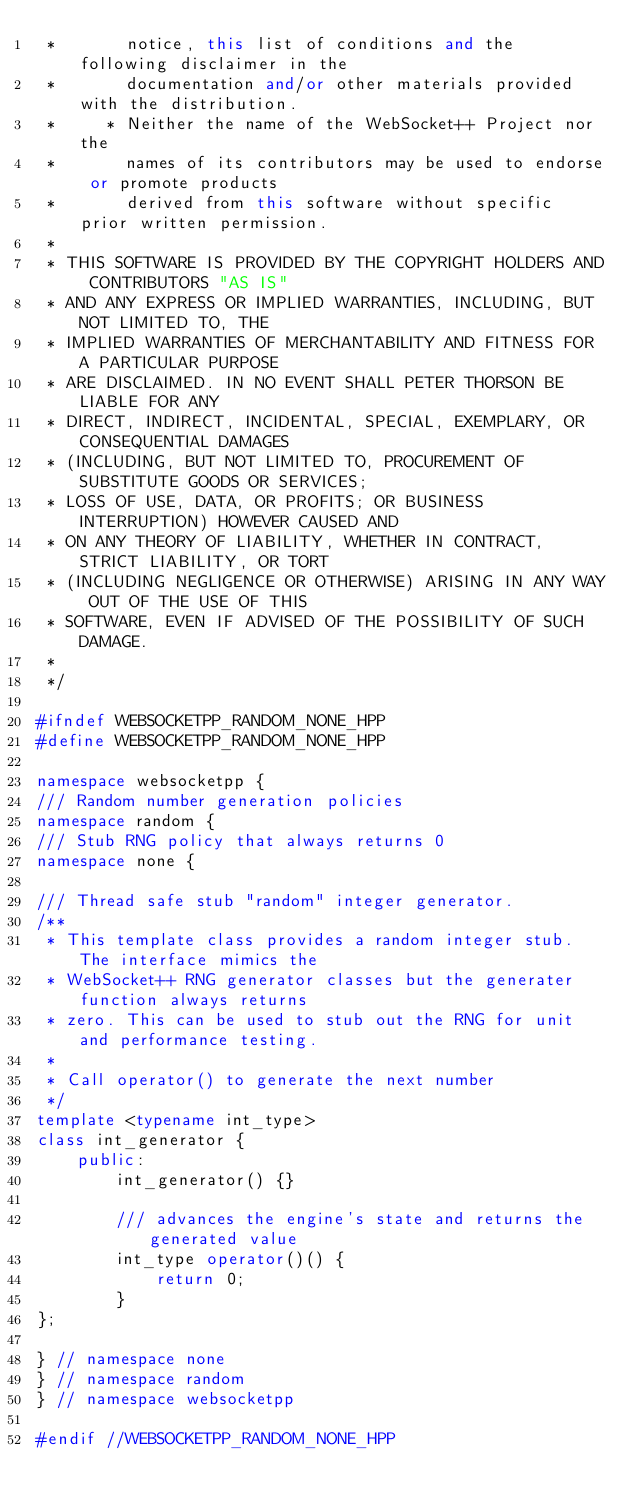Convert code to text. <code><loc_0><loc_0><loc_500><loc_500><_C++_> *       notice, this list of conditions and the following disclaimer in the
 *       documentation and/or other materials provided with the distribution.
 *     * Neither the name of the WebSocket++ Project nor the
 *       names of its contributors may be used to endorse or promote products
 *       derived from this software without specific prior written permission.
 *
 * THIS SOFTWARE IS PROVIDED BY THE COPYRIGHT HOLDERS AND CONTRIBUTORS "AS IS"
 * AND ANY EXPRESS OR IMPLIED WARRANTIES, INCLUDING, BUT NOT LIMITED TO, THE
 * IMPLIED WARRANTIES OF MERCHANTABILITY AND FITNESS FOR A PARTICULAR PURPOSE
 * ARE DISCLAIMED. IN NO EVENT SHALL PETER THORSON BE LIABLE FOR ANY
 * DIRECT, INDIRECT, INCIDENTAL, SPECIAL, EXEMPLARY, OR CONSEQUENTIAL DAMAGES
 * (INCLUDING, BUT NOT LIMITED TO, PROCUREMENT OF SUBSTITUTE GOODS OR SERVICES;
 * LOSS OF USE, DATA, OR PROFITS; OR BUSINESS INTERRUPTION) HOWEVER CAUSED AND
 * ON ANY THEORY OF LIABILITY, WHETHER IN CONTRACT, STRICT LIABILITY, OR TORT
 * (INCLUDING NEGLIGENCE OR OTHERWISE) ARISING IN ANY WAY OUT OF THE USE OF THIS
 * SOFTWARE, EVEN IF ADVISED OF THE POSSIBILITY OF SUCH DAMAGE.
 *
 */

#ifndef WEBSOCKETPP_RANDOM_NONE_HPP
#define WEBSOCKETPP_RANDOM_NONE_HPP

namespace websocketpp {
/// Random number generation policies
namespace random {
/// Stub RNG policy that always returns 0
namespace none {

/// Thread safe stub "random" integer generator.
/**
 * This template class provides a random integer stub. The interface mimics the
 * WebSocket++ RNG generator classes but the generater function always returns
 * zero. This can be used to stub out the RNG for unit and performance testing.
 *
 * Call operator() to generate the next number
 */
template <typename int_type>
class int_generator {
    public:
        int_generator() {}

        /// advances the engine's state and returns the generated value
        int_type operator()() {
            return 0;
        }
};

} // namespace none
} // namespace random
} // namespace websocketpp

#endif //WEBSOCKETPP_RANDOM_NONE_HPP
</code> 